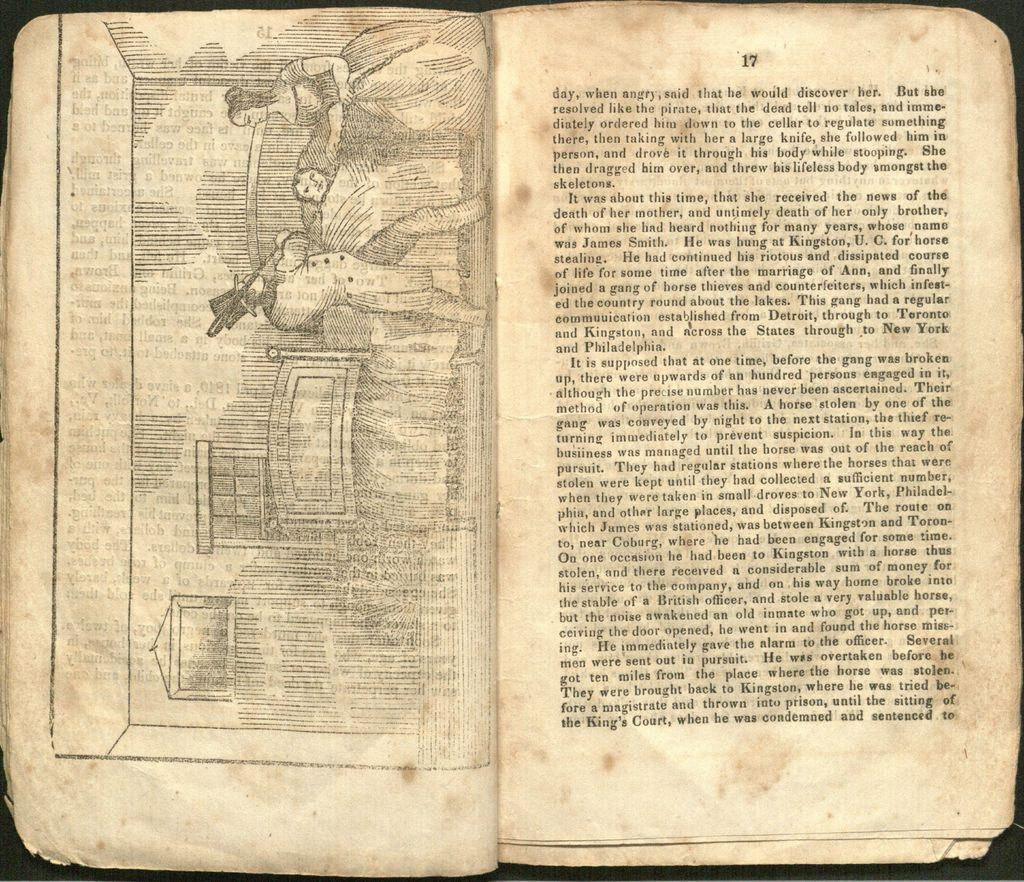<image>
Present a compact description of the photo's key features. old open book with a drawing on the left page and right page is on page 17 